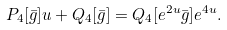<formula> <loc_0><loc_0><loc_500><loc_500>P _ { 4 } [ \bar { g } ] u + Q _ { 4 } [ \bar { g } ] = Q _ { 4 } [ e ^ { 2 u } \bar { g } ] e ^ { 4 u } .</formula> 